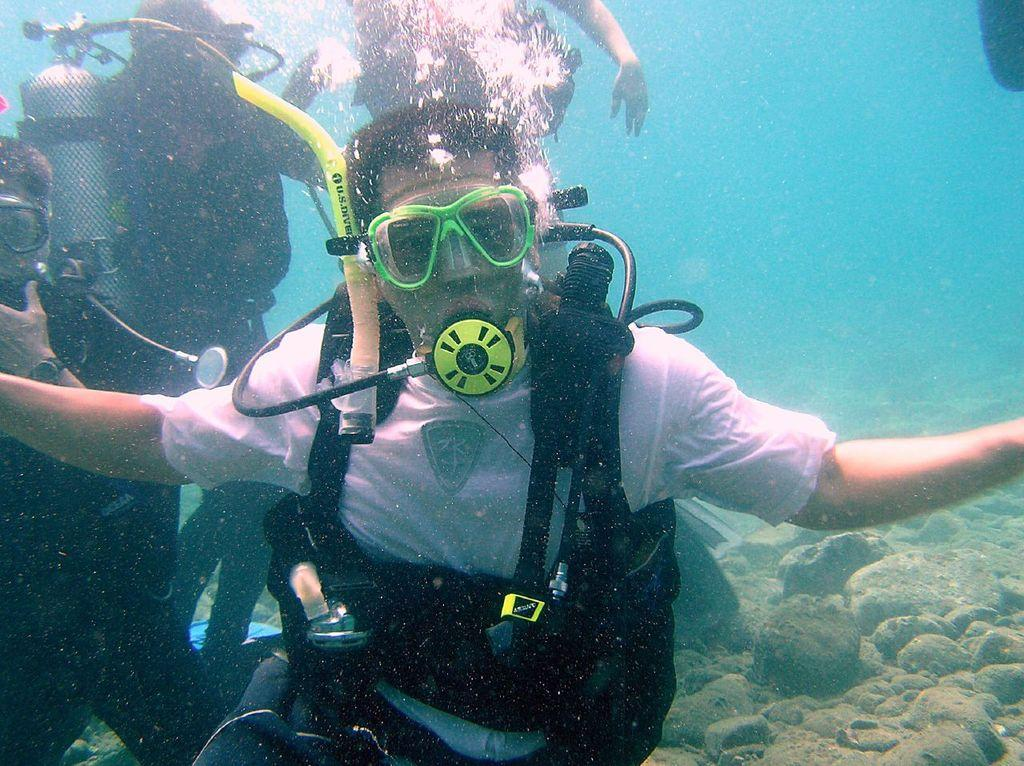What activity are the persons in the image engaged in? The persons in the image are scuba diving. Where is the scuba diving taking place? The scuba diving is taking place in the ocean. What can be seen below the ocean surface in the image? There are rocks visible below the ocean surface. What type of zinc is being used by the scuba divers in the image? There is no zinc present in the image; the scuba divers are not using any zinc-related equipment. 